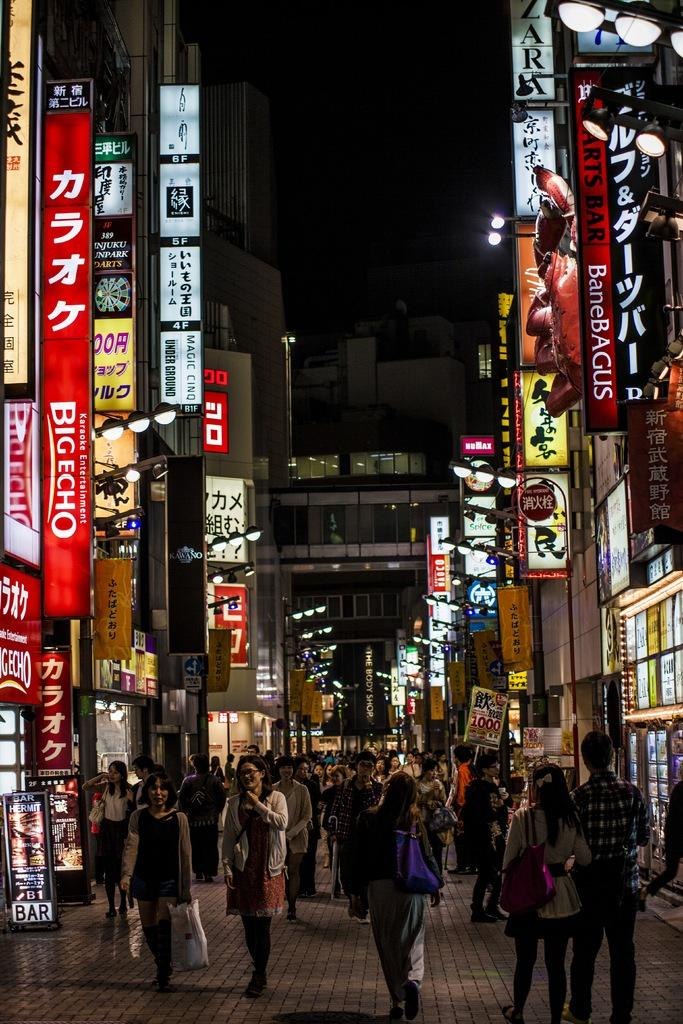What type of location is shown in the image? The image depicts a city. Can you describe the people in the image? There are groups of people standing in the image. What structures are present in the city? There are buildings in the image. What type of signs can be seen in the image? There are boards and light boards in the image. What can be seen in the background of the image? The sky is visible in the background of the image. How many trucks are parked on the street in the image? There are no trucks visible in the image; it only shows groups of people, buildings, boards, and light boards. 